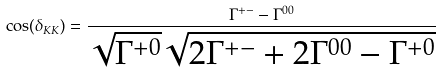Convert formula to latex. <formula><loc_0><loc_0><loc_500><loc_500>\cos ( \delta _ { K K } ) = \frac { \Gamma ^ { + - } - \Gamma ^ { 0 0 } } { \sqrt { \Gamma ^ { + 0 } } \sqrt { 2 \Gamma ^ { + - } + 2 \Gamma ^ { 0 0 } - \Gamma ^ { + 0 } } }</formula> 